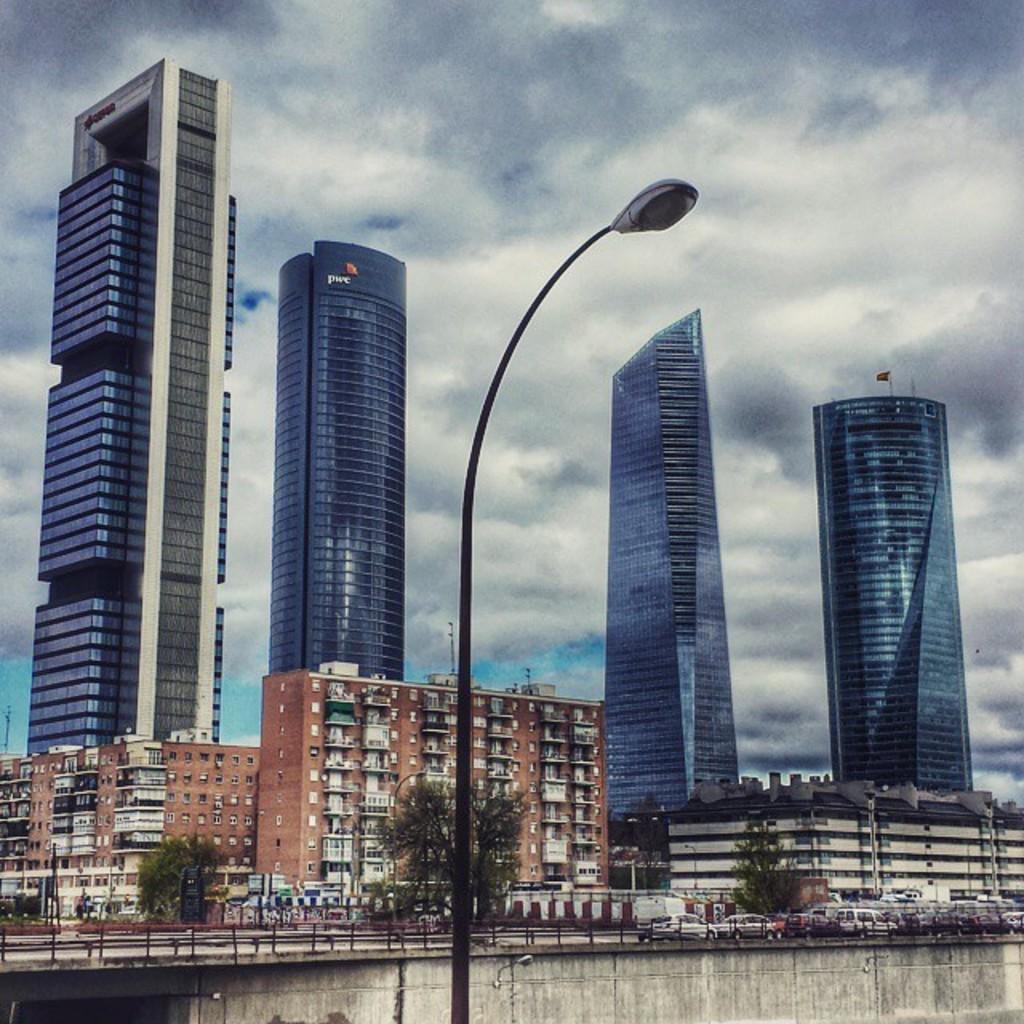What structure can be seen in the image? There is a light pole in the image. What can be seen in the distance in the image? There are vehicles and buildings visible in the background of the image. What is the color of the sky in the image? The sky is blue and white in color. Where are the kittens playing on the swing in the image? There are no kittens or swings present in the image. 